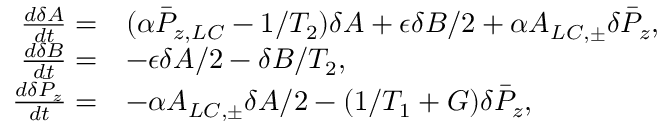<formula> <loc_0><loc_0><loc_500><loc_500>\begin{array} { r l } { \frac { d \delta A } { d t } = } & { ( \alpha \bar { P } _ { z , L C } - 1 / T _ { 2 } ) \delta A + \epsilon \delta B / 2 + \alpha A _ { L C , \pm } \delta \bar { P } _ { z } , } \\ { \frac { d \delta B } { d t } = } & { - \epsilon \delta A / 2 - \delta B / T _ { 2 } , } \\ { \frac { d \delta \bar { P } _ { z } } { d t } = } & { - \alpha A _ { L C , \pm } \delta A / 2 - ( 1 / T _ { 1 } + G ) \delta \bar { P } _ { z } , } \end{array}</formula> 